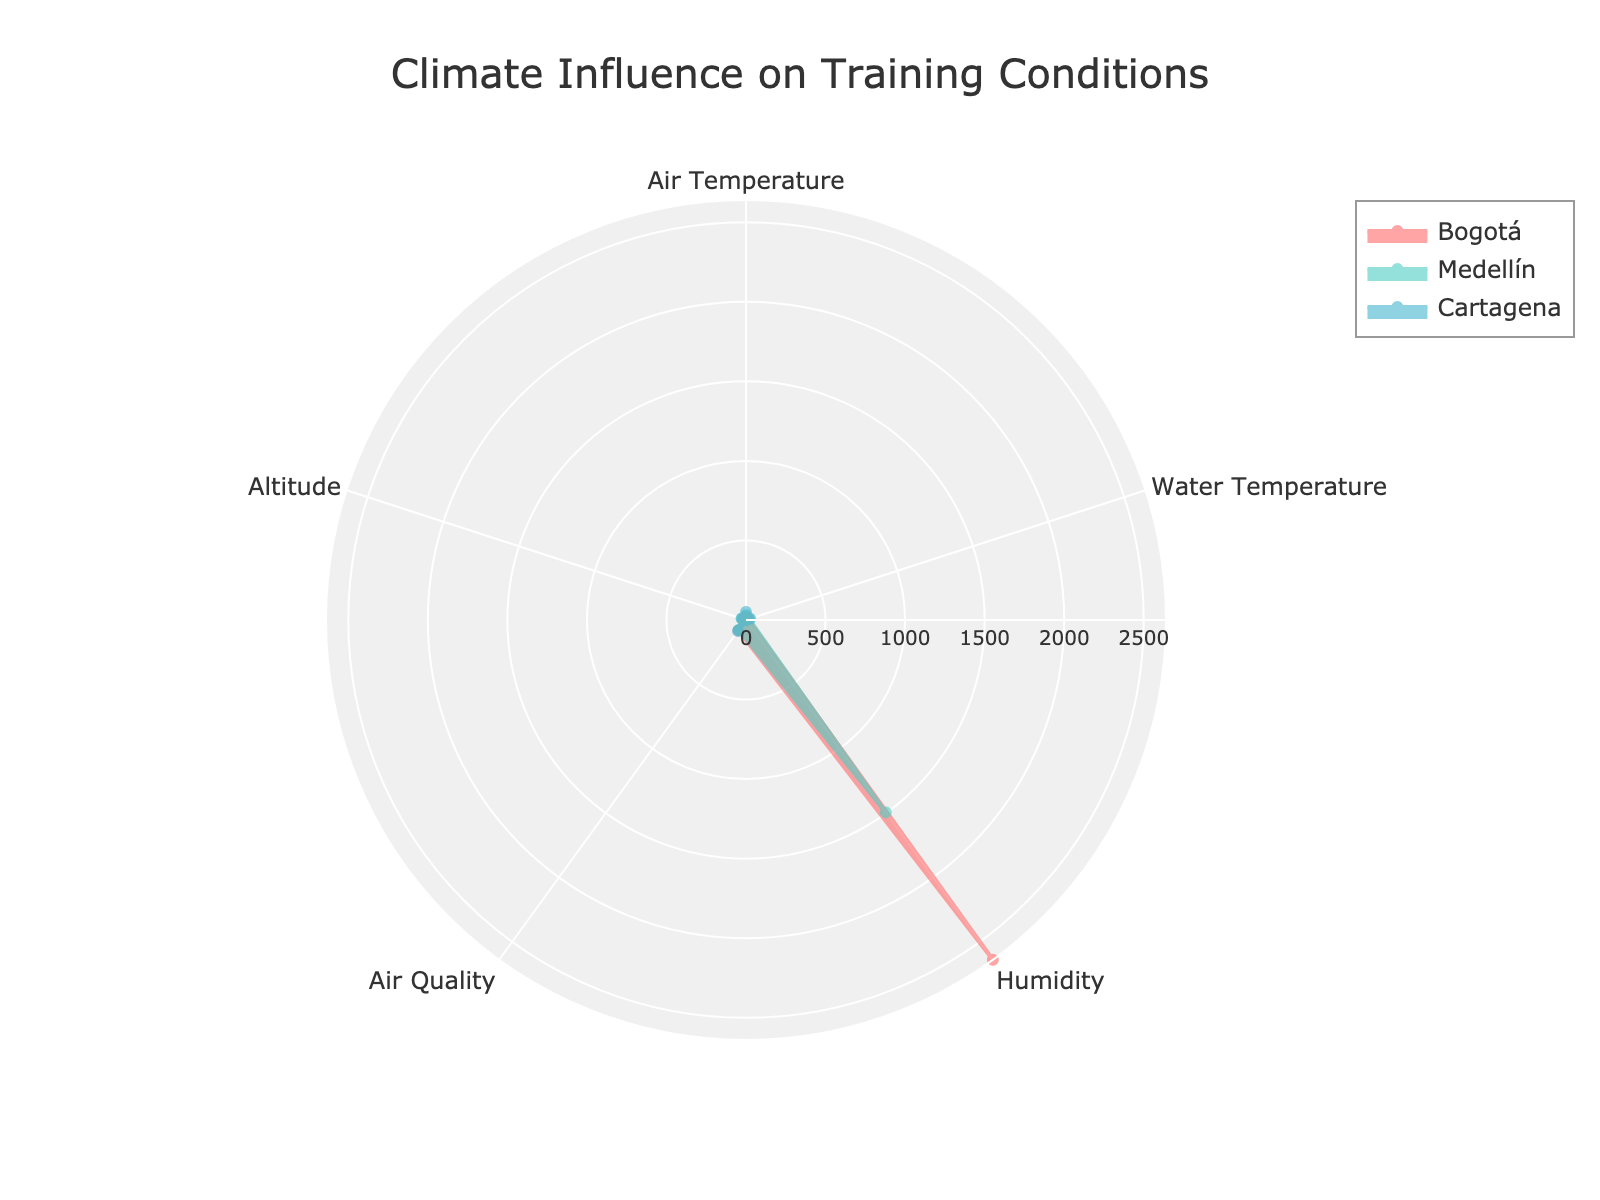What's the title of the radar chart? The title is located at the top of the chart in larger font size and usually provides a summary of what the chart represents.
Answer: Climate Influence on Training Conditions Which city has the warmest air temperature on average? By examining the radar chart, we can compare the air temperature data point for each city. The city with the largest value in that metric is the warmest.
Answer: Cartagena What is the average altitude of the three cities? The altitude values for Bogotá, Medellín, and Cartagena can be summed up and then divided by the number of cities (3). Sum = 2640 + 1495 + 2 = 4137. Average = 4137 / 3.
Answer: 1379 Which city has the highest humidity? By looking at the humidity data points on the radar chart, the city with the highest value will be clear.
Answer: Cartagena Which city has better air quality on average, Bogotá or Medellín? Comparing the air quality values for Bogotá and Medellín on the radar chart, we can see which city has lower values, indicating better air quality.
Answer: Bogotá Compare the water temperature in Cartagena to that in Medellín. Which city has higher values? On the radar chart, look at the water temperature metric for both Cartagena and Medellín. The city with the higher values is Cartagena.
Answer: Cartagena Is the air temperature in Bogotá consistent throughout the year? By observing the air temperature data point for Bogotá on the radar chart, if the line is close to circular, it indicates that the values are consistent throughout the year.
Answer: Yes What is the range of air quality values for all locations? According to the radar chart, the minimum air quality value is observed for Bogotá (~20) and the maximum for Cartagena (~52). The range is the difference between them. 52 - 20 = 32.
Answer: 32 How does the average water temperature in Bogotá compare to its air temperature? By examining the water temperature and air temperature data points for Bogotá, we can observe if there is a significant difference between the two values.
Answer: Water temperature is higher Which metric exhibits the most variation across the three cities? The metric with the widest range of values on the radar chart (longest distance between the smallest and largest values within the same metric) is the one with the most variation.
Answer: Altitude 